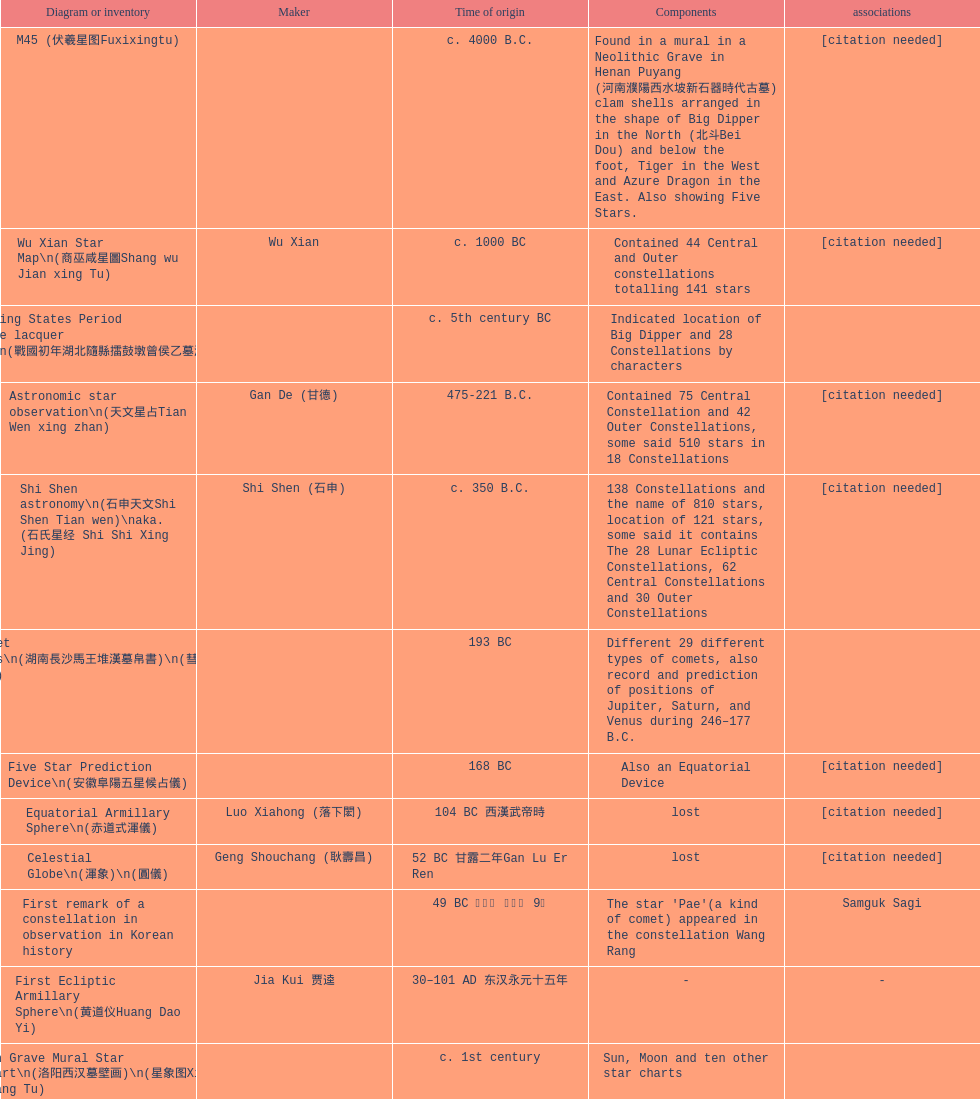When was the first map or catalog created? C. 4000 b.c. 